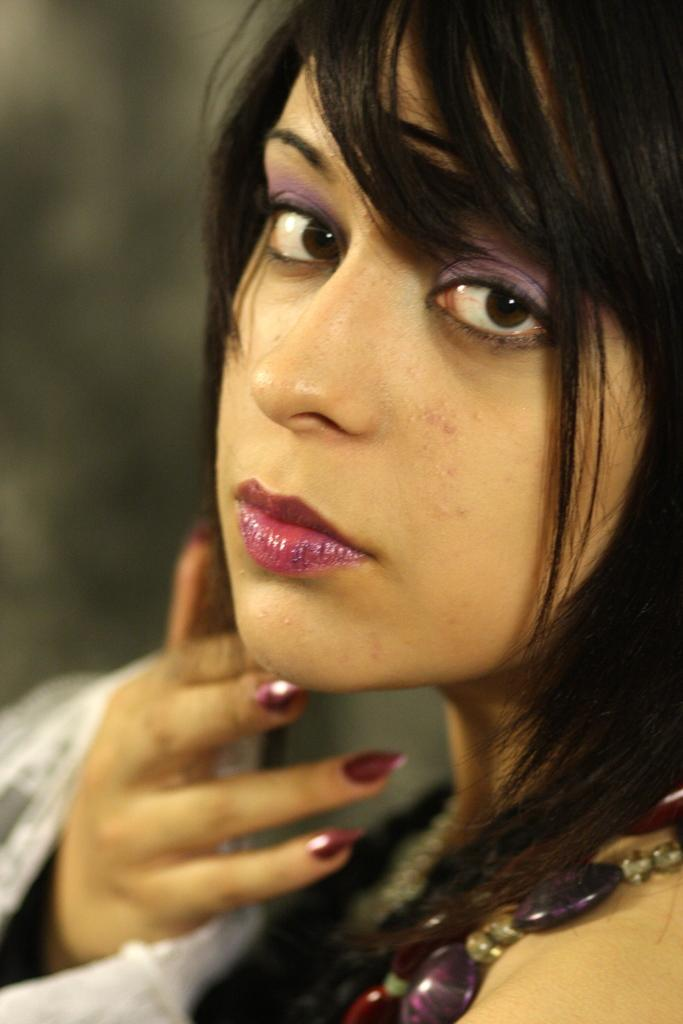What is the main subject of the image? There is an image of a woman in the middle of the image. What type of tree is present in the room with the woman? There is no tree present in the image, as it only features an image of a woman. 